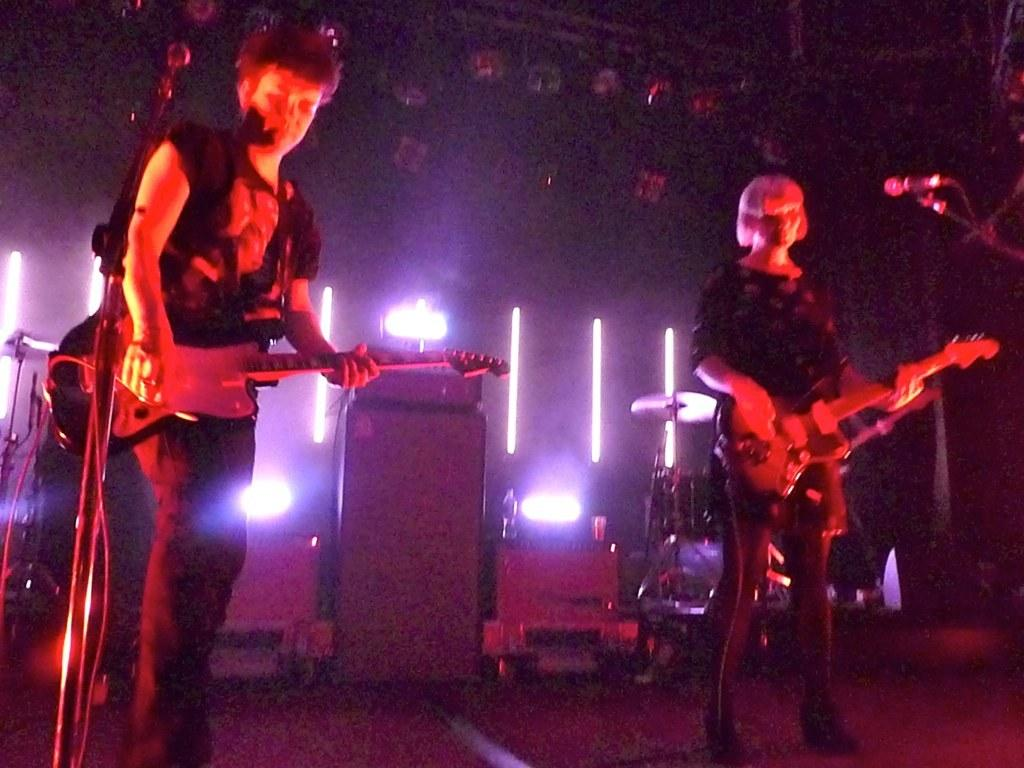What are the persons in the image holding? The persons in the image are holding guitars. Where are the persons standing in the image? The persons are standing on the ground. What can be seen in the background of the image? There are lights, musical instruments, water bottles, and a wall in the background of the image. What type of dirt can be seen on the fangs of the persons in the image? There are no fangs or dirt present in the image; the persons are holding guitars and standing on the ground. 